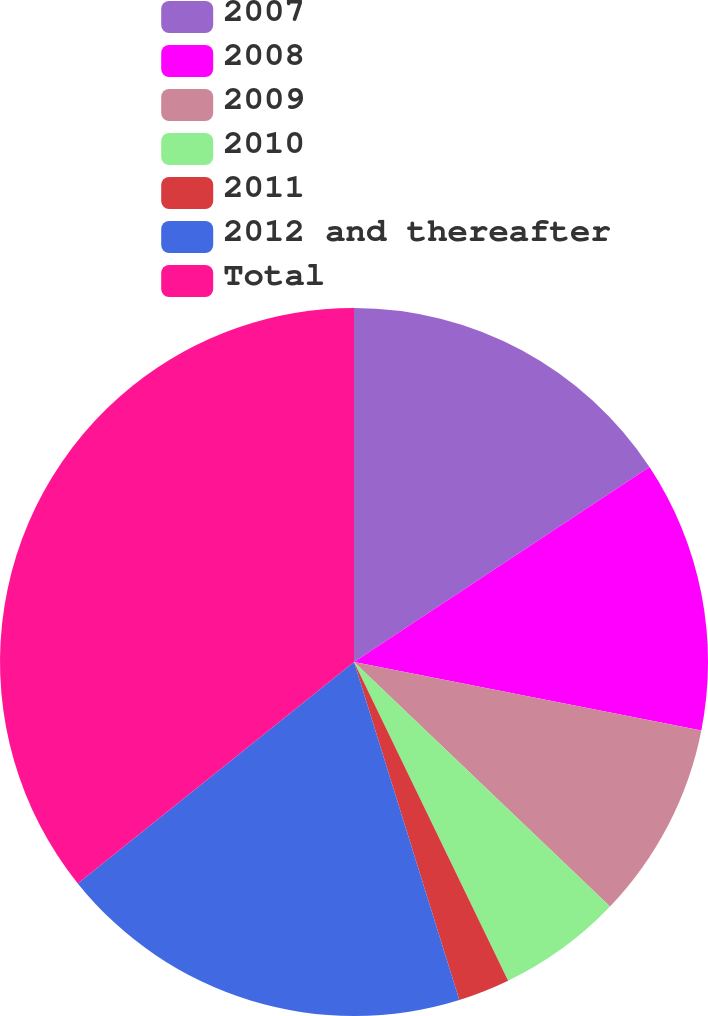Convert chart. <chart><loc_0><loc_0><loc_500><loc_500><pie_chart><fcel>2007<fcel>2008<fcel>2009<fcel>2010<fcel>2011<fcel>2012 and thereafter<fcel>Total<nl><fcel>15.72%<fcel>12.38%<fcel>9.04%<fcel>5.7%<fcel>2.36%<fcel>19.06%<fcel>35.76%<nl></chart> 